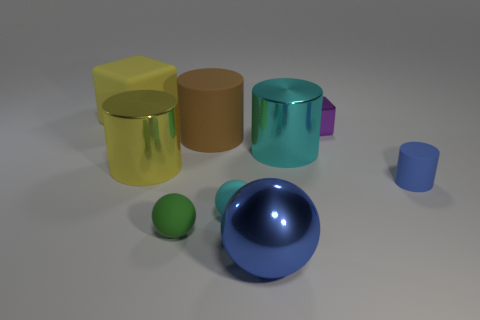Do the brown matte cylinder and the yellow matte thing have the same size?
Your answer should be very brief. Yes. Are there an equal number of large yellow cylinders that are right of the brown cylinder and cyan rubber blocks?
Make the answer very short. Yes. There is a big yellow thing that is behind the tiny metal thing; is there a cube in front of it?
Keep it short and to the point. Yes. There is a cylinder that is to the right of the cube that is right of the yellow object that is behind the purple thing; how big is it?
Keep it short and to the point. Small. There is a small blue object on the right side of the big cylinder that is in front of the big cyan metal cylinder; what is its material?
Your response must be concise. Rubber. Are there any other green things that have the same shape as the small green object?
Keep it short and to the point. No. The small cyan rubber thing has what shape?
Provide a short and direct response. Sphere. There is a cylinder that is in front of the shiny cylinder on the left side of the shiny cylinder to the right of the big blue metal sphere; what is its material?
Keep it short and to the point. Rubber. Are there more small things that are right of the big brown rubber cylinder than big blue objects?
Offer a terse response. Yes. What material is the yellow thing that is the same size as the yellow shiny cylinder?
Your answer should be compact. Rubber. 